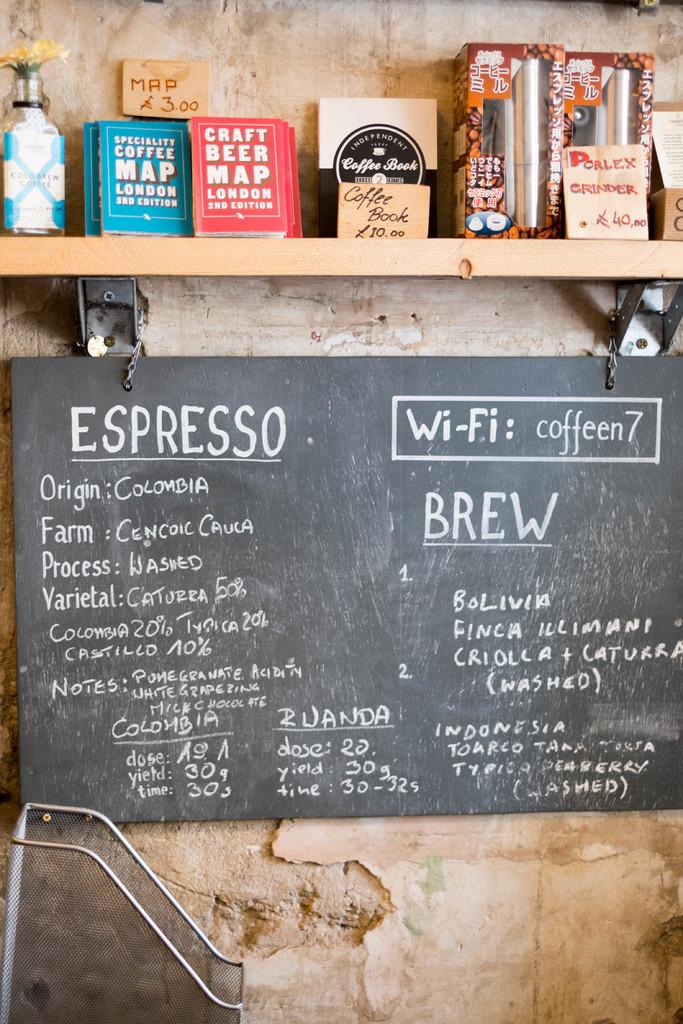What beverages do they sell here?
Offer a very short reply. Espresso, brew. 